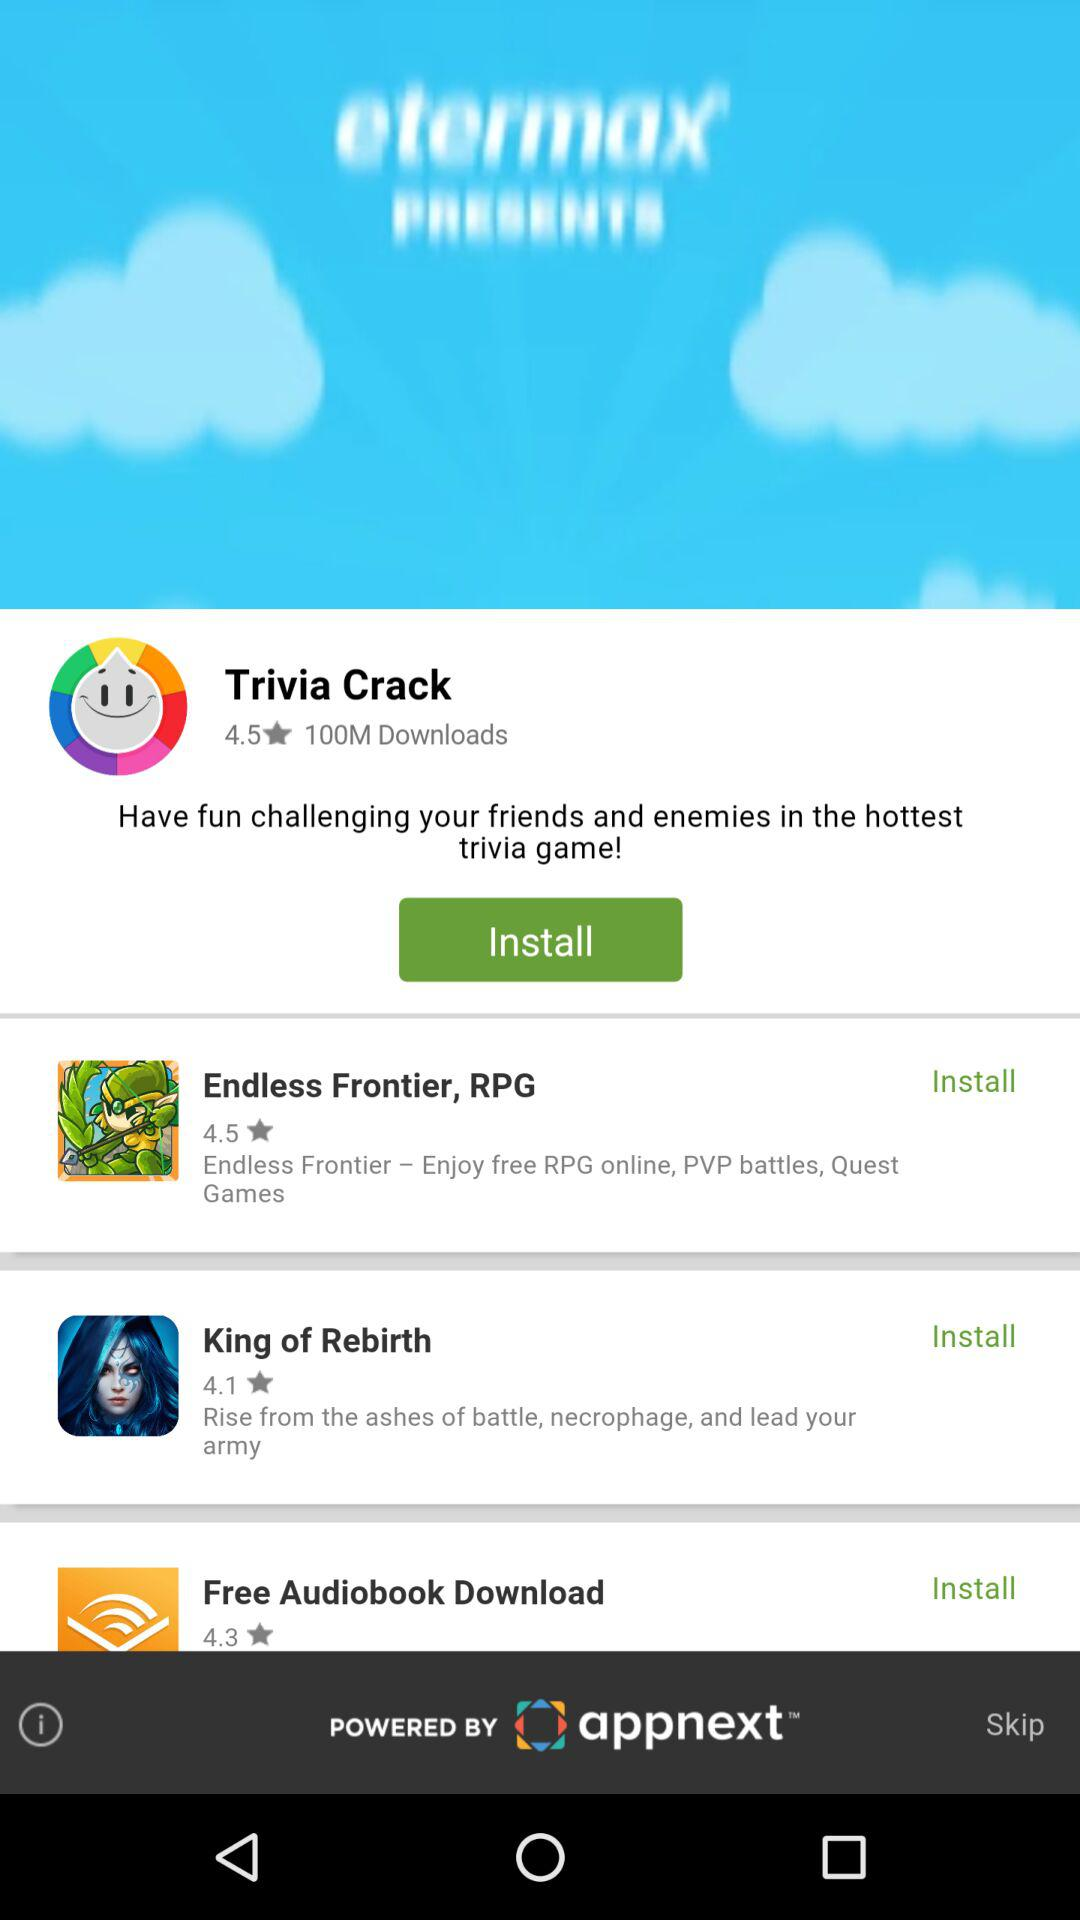How many downloads are there for "Trivia Crack"? There are 100 million downloads for "Trivia Crack". 